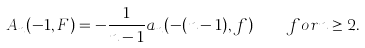Convert formula to latex. <formula><loc_0><loc_0><loc_500><loc_500>A _ { n } ( - 1 , F ) = - \frac { 1 } { n - 1 } a _ { n } ( - ( n - 1 ) , f ) \quad f o r n \geq 2 .</formula> 